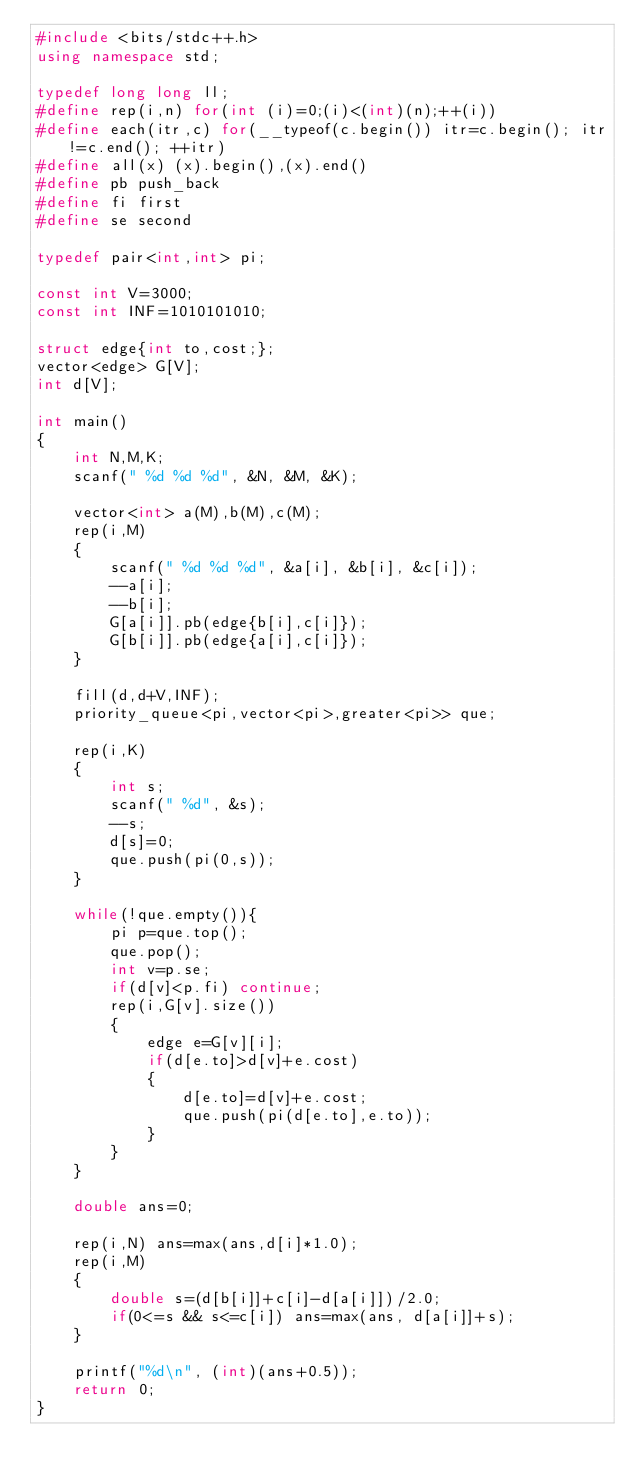Convert code to text. <code><loc_0><loc_0><loc_500><loc_500><_C++_>#include <bits/stdc++.h>
using namespace std;

typedef long long ll;
#define rep(i,n) for(int (i)=0;(i)<(int)(n);++(i))
#define each(itr,c) for(__typeof(c.begin()) itr=c.begin(); itr!=c.end(); ++itr)
#define all(x) (x).begin(),(x).end()
#define pb push_back
#define fi first
#define se second

typedef pair<int,int> pi;

const int V=3000;
const int INF=1010101010;

struct edge{int to,cost;};
vector<edge> G[V];
int d[V];

int main()
{
    int N,M,K;
    scanf(" %d %d %d", &N, &M, &K);

    vector<int> a(M),b(M),c(M);
    rep(i,M)
    {
        scanf(" %d %d %d", &a[i], &b[i], &c[i]);
        --a[i];
        --b[i];
        G[a[i]].pb(edge{b[i],c[i]});
        G[b[i]].pb(edge{a[i],c[i]});
    }

    fill(d,d+V,INF);
    priority_queue<pi,vector<pi>,greater<pi>> que;

    rep(i,K)
    {
        int s;
        scanf(" %d", &s);
        --s;
        d[s]=0;
        que.push(pi(0,s));
    }

    while(!que.empty()){
        pi p=que.top();
        que.pop();
        int v=p.se;
        if(d[v]<p.fi) continue;
        rep(i,G[v].size())
        {
            edge e=G[v][i];
            if(d[e.to]>d[v]+e.cost)
            {
                d[e.to]=d[v]+e.cost;
                que.push(pi(d[e.to],e.to));
            }
        }
    }

    double ans=0;

    rep(i,N) ans=max(ans,d[i]*1.0);
    rep(i,M)
    {
        double s=(d[b[i]]+c[i]-d[a[i]])/2.0;
        if(0<=s && s<=c[i]) ans=max(ans, d[a[i]]+s);
    }

    printf("%d\n", (int)(ans+0.5));
    return 0;
}</code> 